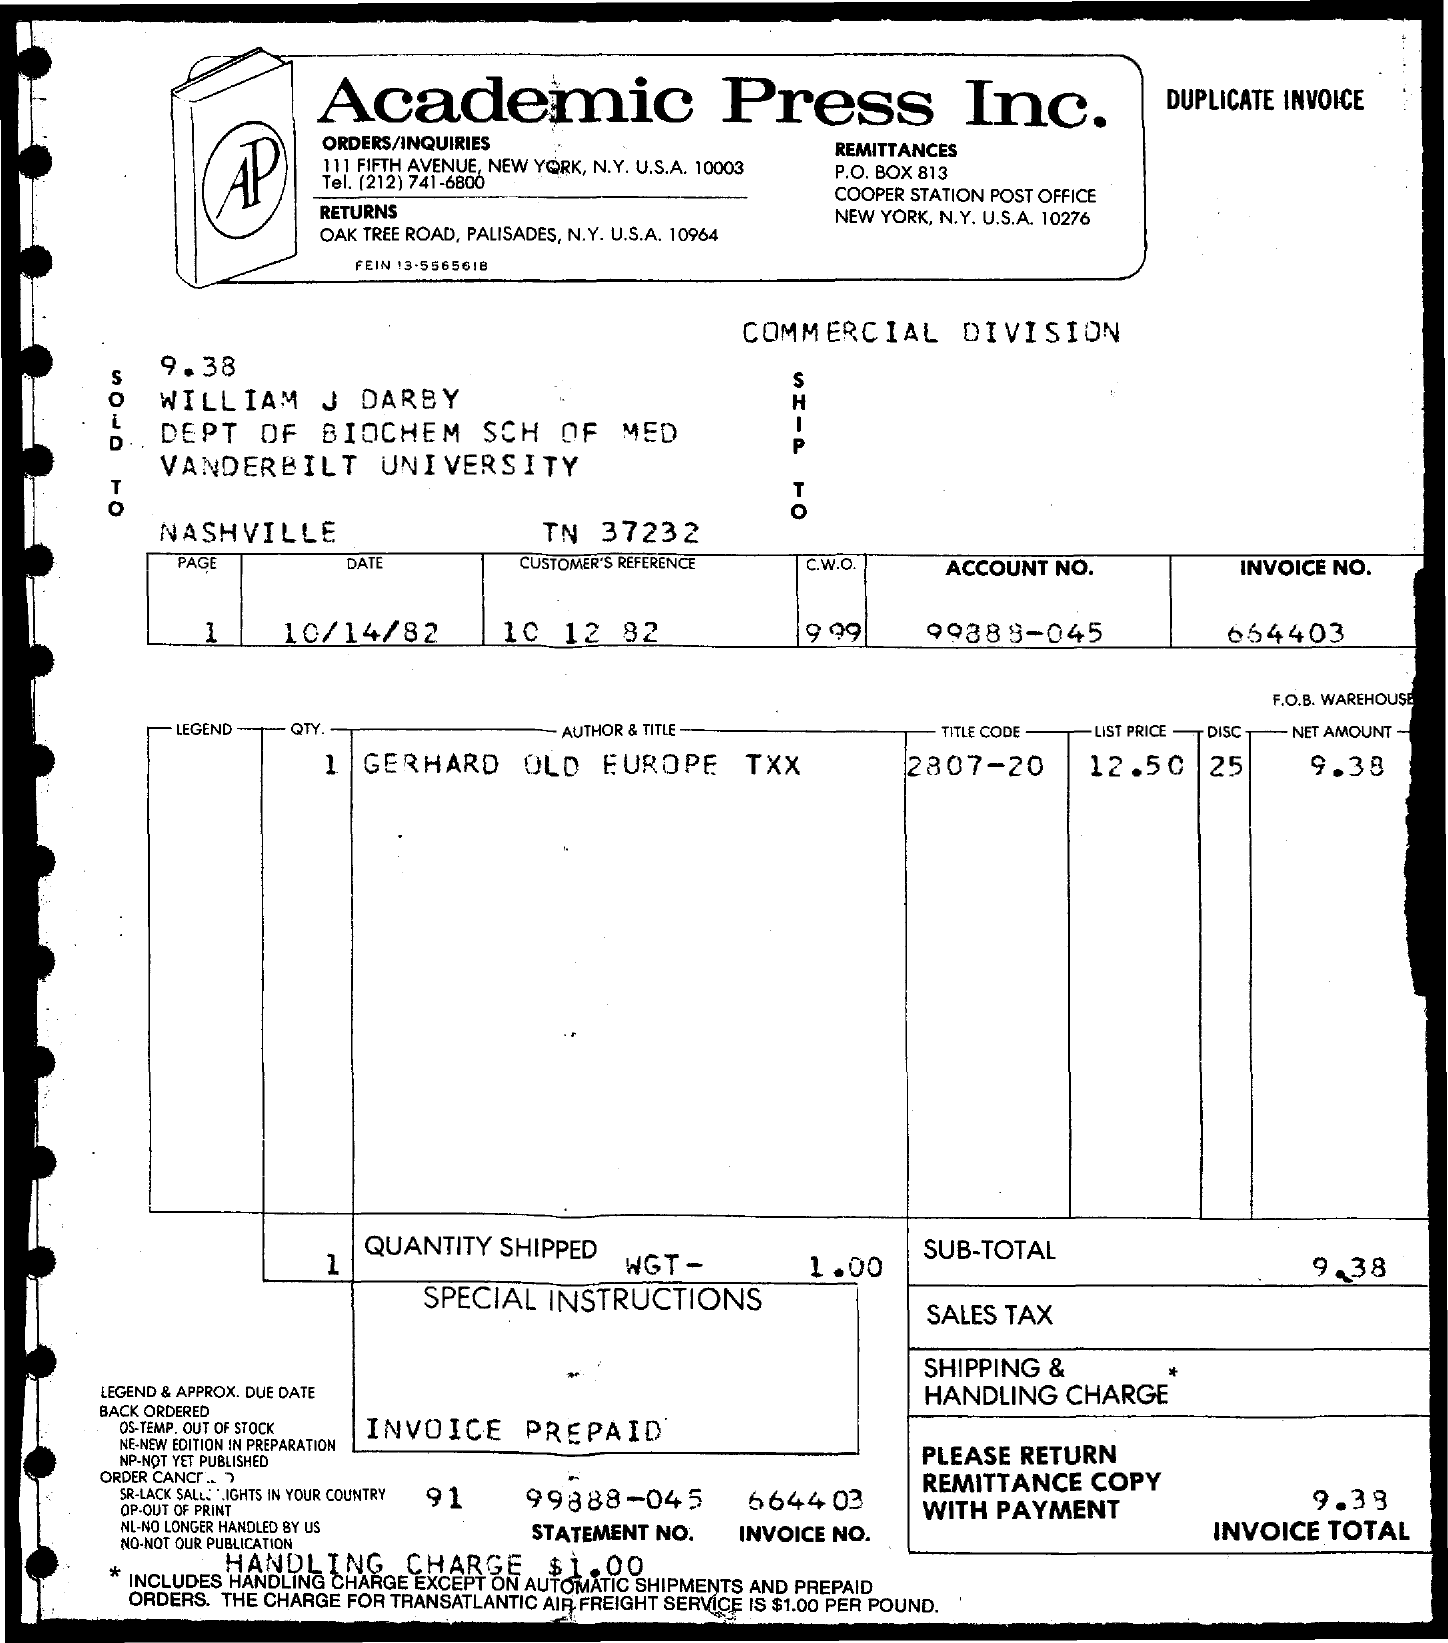What is the date of this transaction? The date of the transaction listed on the invoice is January 14, 1982. Could you provide me with the address the item was shipped to? The item was shipped to William J Darby at the Department of Biochemistry School of Medicine, Vanderbilt University, located in Nashville, TN 37232. 